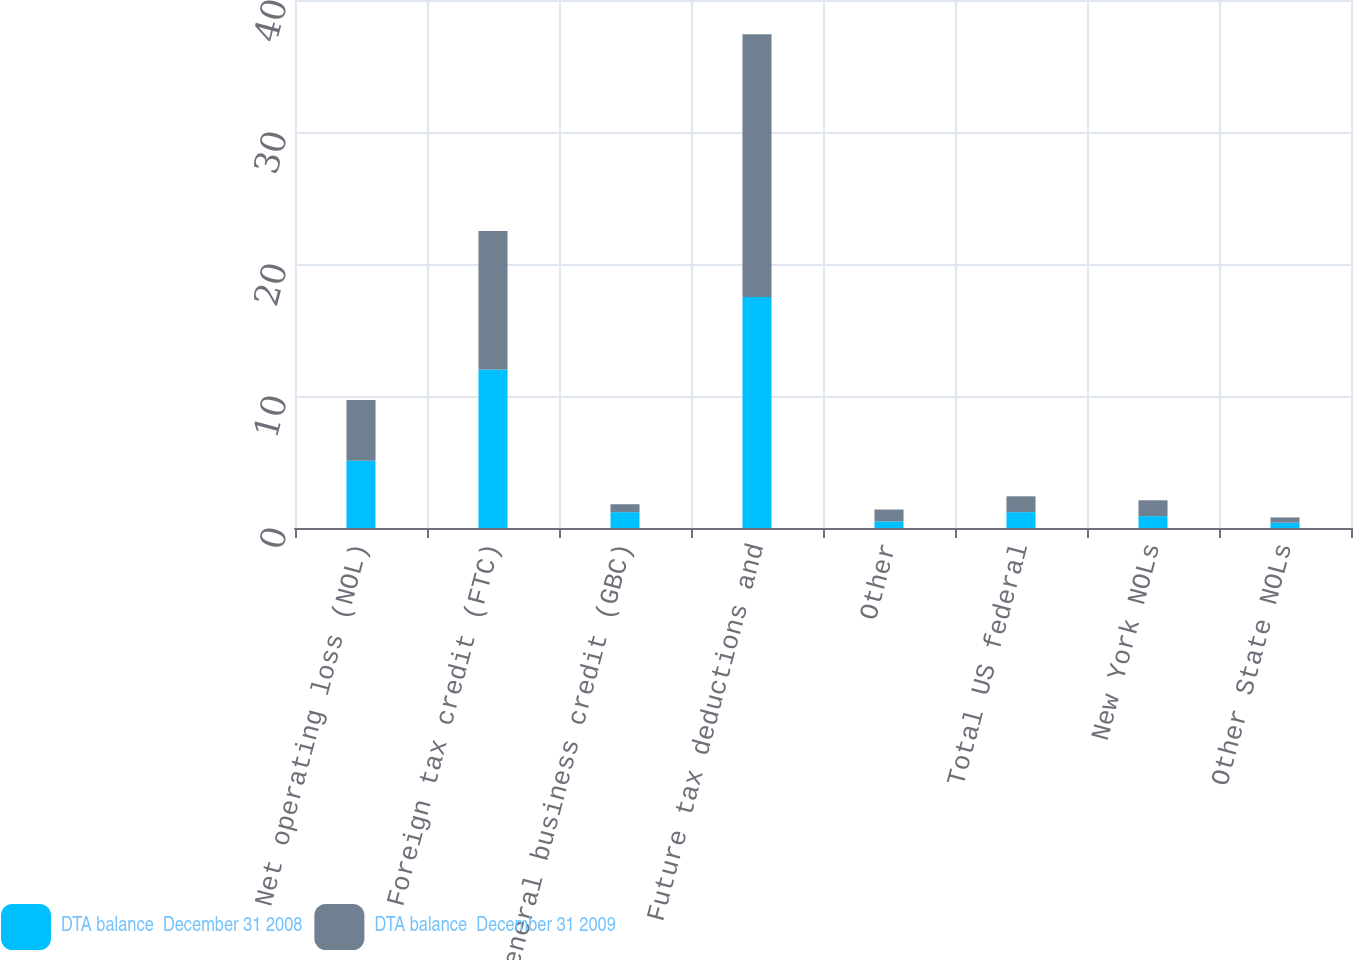<chart> <loc_0><loc_0><loc_500><loc_500><stacked_bar_chart><ecel><fcel>Net operating loss (NOL)<fcel>Foreign tax credit (FTC)<fcel>General business credit (GBC)<fcel>Future tax deductions and<fcel>Other<fcel>Total US federal<fcel>New York NOLs<fcel>Other State NOLs<nl><fcel>DTA balance  December 31 2008<fcel>5.1<fcel>12<fcel>1.2<fcel>17.5<fcel>0.5<fcel>1.2<fcel>0.9<fcel>0.4<nl><fcel>DTA balance  December 31 2009<fcel>4.6<fcel>10.5<fcel>0.6<fcel>19.9<fcel>0.9<fcel>1.2<fcel>1.2<fcel>0.4<nl></chart> 